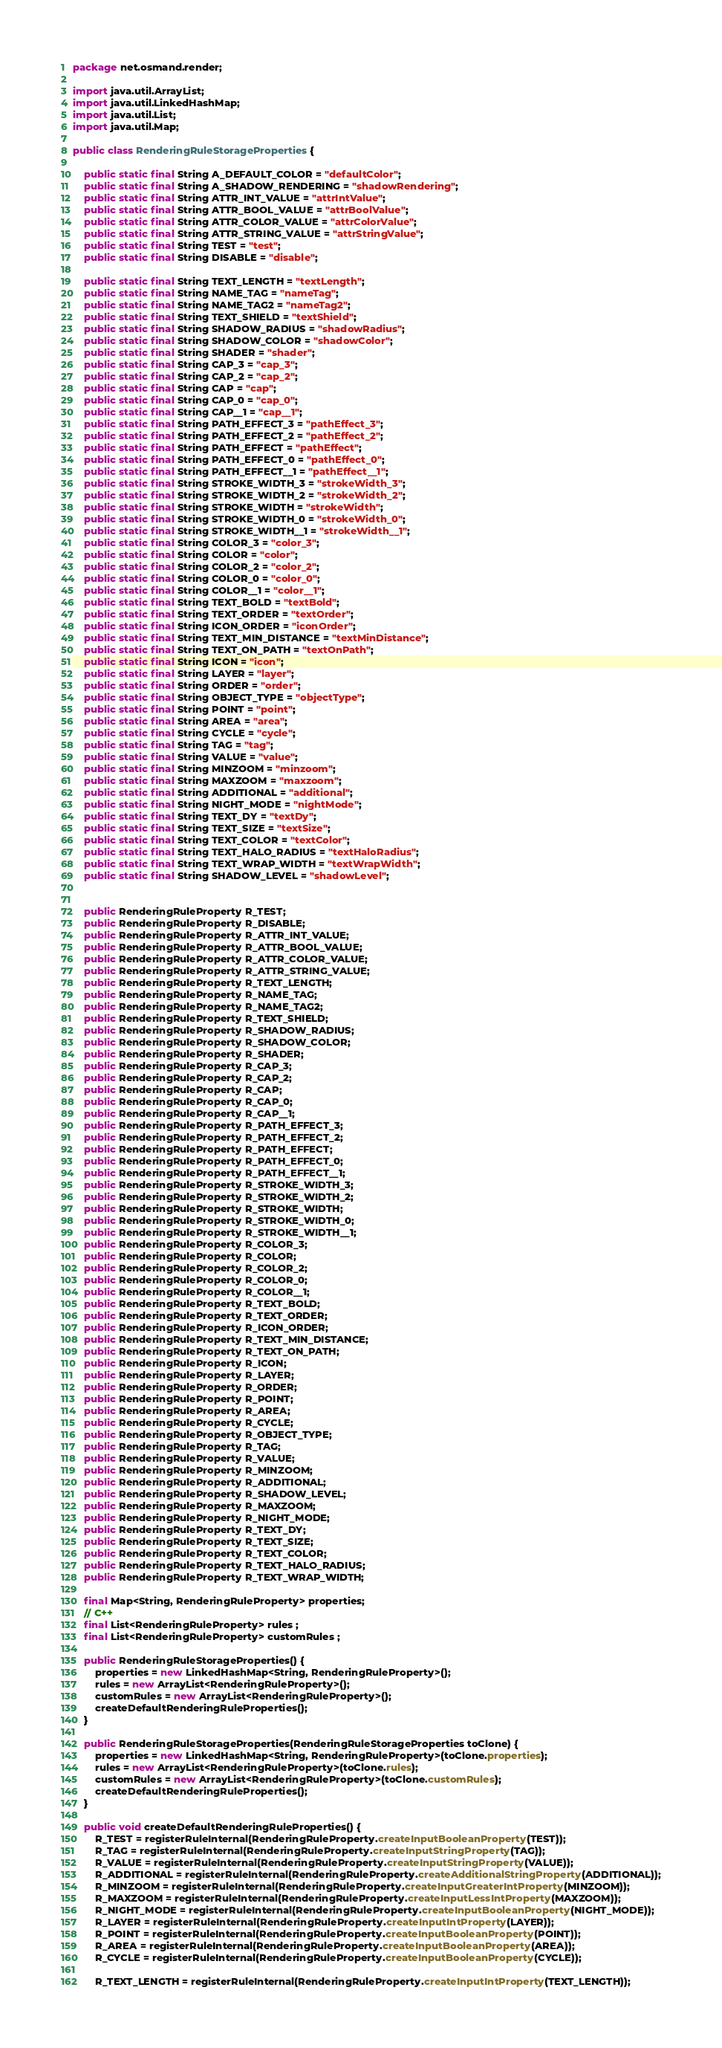<code> <loc_0><loc_0><loc_500><loc_500><_Java_>package net.osmand.render;

import java.util.ArrayList;
import java.util.LinkedHashMap;
import java.util.List;
import java.util.Map;

public class RenderingRuleStorageProperties {

	public static final String A_DEFAULT_COLOR = "defaultColor";
	public static final String A_SHADOW_RENDERING = "shadowRendering";
	public static final String ATTR_INT_VALUE = "attrIntValue";
	public static final String ATTR_BOOL_VALUE = "attrBoolValue";
	public static final String ATTR_COLOR_VALUE = "attrColorValue";
	public static final String ATTR_STRING_VALUE = "attrStringValue";
	public static final String TEST = "test";
	public static final String DISABLE = "disable";
	
	public static final String TEXT_LENGTH = "textLength";
	public static final String NAME_TAG = "nameTag";
	public static final String NAME_TAG2 = "nameTag2";
	public static final String TEXT_SHIELD = "textShield";
	public static final String SHADOW_RADIUS = "shadowRadius";
	public static final String SHADOW_COLOR = "shadowColor";
	public static final String SHADER = "shader";
	public static final String CAP_3 = "cap_3";
	public static final String CAP_2 = "cap_2";
	public static final String CAP = "cap";
	public static final String CAP_0 = "cap_0";
	public static final String CAP__1 = "cap__1";
	public static final String PATH_EFFECT_3 = "pathEffect_3";
	public static final String PATH_EFFECT_2 = "pathEffect_2";
	public static final String PATH_EFFECT = "pathEffect";
	public static final String PATH_EFFECT_0 = "pathEffect_0";
	public static final String PATH_EFFECT__1 = "pathEffect__1";
	public static final String STROKE_WIDTH_3 = "strokeWidth_3";
	public static final String STROKE_WIDTH_2 = "strokeWidth_2";
	public static final String STROKE_WIDTH = "strokeWidth";
	public static final String STROKE_WIDTH_0 = "strokeWidth_0";
	public static final String STROKE_WIDTH__1 = "strokeWidth__1";
	public static final String COLOR_3 = "color_3";
	public static final String COLOR = "color";
	public static final String COLOR_2 = "color_2";
	public static final String COLOR_0 = "color_0";
	public static final String COLOR__1 = "color__1";
	public static final String TEXT_BOLD = "textBold";
	public static final String TEXT_ORDER = "textOrder";
	public static final String ICON_ORDER = "iconOrder";
	public static final String TEXT_MIN_DISTANCE = "textMinDistance";
	public static final String TEXT_ON_PATH = "textOnPath";
	public static final String ICON = "icon";
	public static final String LAYER = "layer";
	public static final String ORDER = "order";
	public static final String OBJECT_TYPE = "objectType";
	public static final String POINT = "point";
	public static final String AREA = "area";
	public static final String CYCLE = "cycle";
	public static final String TAG = "tag";
	public static final String VALUE = "value";
	public static final String MINZOOM = "minzoom";
	public static final String MAXZOOM = "maxzoom";
	public static final String ADDITIONAL = "additional";
	public static final String NIGHT_MODE = "nightMode";
	public static final String TEXT_DY = "textDy";
	public static final String TEXT_SIZE = "textSize";
	public static final String TEXT_COLOR = "textColor";
	public static final String TEXT_HALO_RADIUS = "textHaloRadius";
	public static final String TEXT_WRAP_WIDTH = "textWrapWidth";
	public static final String SHADOW_LEVEL = "shadowLevel";

	
	public RenderingRuleProperty R_TEST;
	public RenderingRuleProperty R_DISABLE;
	public RenderingRuleProperty R_ATTR_INT_VALUE;
	public RenderingRuleProperty R_ATTR_BOOL_VALUE;
	public RenderingRuleProperty R_ATTR_COLOR_VALUE;
	public RenderingRuleProperty R_ATTR_STRING_VALUE;
	public RenderingRuleProperty R_TEXT_LENGTH;
	public RenderingRuleProperty R_NAME_TAG;
	public RenderingRuleProperty R_NAME_TAG2;
	public RenderingRuleProperty R_TEXT_SHIELD;
	public RenderingRuleProperty R_SHADOW_RADIUS;
	public RenderingRuleProperty R_SHADOW_COLOR;
	public RenderingRuleProperty R_SHADER;
	public RenderingRuleProperty R_CAP_3;
	public RenderingRuleProperty R_CAP_2;
	public RenderingRuleProperty R_CAP;
	public RenderingRuleProperty R_CAP_0;
	public RenderingRuleProperty R_CAP__1;
	public RenderingRuleProperty R_PATH_EFFECT_3;
	public RenderingRuleProperty R_PATH_EFFECT_2;
	public RenderingRuleProperty R_PATH_EFFECT;
	public RenderingRuleProperty R_PATH_EFFECT_0;
	public RenderingRuleProperty R_PATH_EFFECT__1;
	public RenderingRuleProperty R_STROKE_WIDTH_3;
	public RenderingRuleProperty R_STROKE_WIDTH_2;
	public RenderingRuleProperty R_STROKE_WIDTH;
	public RenderingRuleProperty R_STROKE_WIDTH_0;
	public RenderingRuleProperty R_STROKE_WIDTH__1;
	public RenderingRuleProperty R_COLOR_3;
	public RenderingRuleProperty R_COLOR;
	public RenderingRuleProperty R_COLOR_2;
	public RenderingRuleProperty R_COLOR_0;
	public RenderingRuleProperty R_COLOR__1;
	public RenderingRuleProperty R_TEXT_BOLD;
	public RenderingRuleProperty R_TEXT_ORDER;
	public RenderingRuleProperty R_ICON_ORDER;
	public RenderingRuleProperty R_TEXT_MIN_DISTANCE;
	public RenderingRuleProperty R_TEXT_ON_PATH;
	public RenderingRuleProperty R_ICON;
	public RenderingRuleProperty R_LAYER;
	public RenderingRuleProperty R_ORDER;
	public RenderingRuleProperty R_POINT;
	public RenderingRuleProperty R_AREA;
	public RenderingRuleProperty R_CYCLE;
	public RenderingRuleProperty R_OBJECT_TYPE;
	public RenderingRuleProperty R_TAG;
	public RenderingRuleProperty R_VALUE;
	public RenderingRuleProperty R_MINZOOM;
	public RenderingRuleProperty R_ADDITIONAL;
	public RenderingRuleProperty R_SHADOW_LEVEL;
	public RenderingRuleProperty R_MAXZOOM;
	public RenderingRuleProperty R_NIGHT_MODE;
	public RenderingRuleProperty R_TEXT_DY;
	public RenderingRuleProperty R_TEXT_SIZE;
	public RenderingRuleProperty R_TEXT_COLOR;
	public RenderingRuleProperty R_TEXT_HALO_RADIUS;
	public RenderingRuleProperty R_TEXT_WRAP_WIDTH;

	final Map<String, RenderingRuleProperty> properties;
	// C++
	final List<RenderingRuleProperty> rules ;
	final List<RenderingRuleProperty> customRules ;
	
	public RenderingRuleStorageProperties() {
		properties = new LinkedHashMap<String, RenderingRuleProperty>();
		rules = new ArrayList<RenderingRuleProperty>();
		customRules = new ArrayList<RenderingRuleProperty>();
		createDefaultRenderingRuleProperties();
	}
	
	public RenderingRuleStorageProperties(RenderingRuleStorageProperties toClone) {
		properties = new LinkedHashMap<String, RenderingRuleProperty>(toClone.properties);
		rules = new ArrayList<RenderingRuleProperty>(toClone.rules);
		customRules = new ArrayList<RenderingRuleProperty>(toClone.customRules);
		createDefaultRenderingRuleProperties();
	}

	public void createDefaultRenderingRuleProperties() {
		R_TEST = registerRuleInternal(RenderingRuleProperty.createInputBooleanProperty(TEST));
		R_TAG = registerRuleInternal(RenderingRuleProperty.createInputStringProperty(TAG));
		R_VALUE = registerRuleInternal(RenderingRuleProperty.createInputStringProperty(VALUE));
		R_ADDITIONAL = registerRuleInternal(RenderingRuleProperty.createAdditionalStringProperty(ADDITIONAL));
		R_MINZOOM = registerRuleInternal(RenderingRuleProperty.createInputGreaterIntProperty(MINZOOM));
		R_MAXZOOM = registerRuleInternal(RenderingRuleProperty.createInputLessIntProperty(MAXZOOM));
		R_NIGHT_MODE = registerRuleInternal(RenderingRuleProperty.createInputBooleanProperty(NIGHT_MODE));
		R_LAYER = registerRuleInternal(RenderingRuleProperty.createInputIntProperty(LAYER));
		R_POINT = registerRuleInternal(RenderingRuleProperty.createInputBooleanProperty(POINT));
		R_AREA = registerRuleInternal(RenderingRuleProperty.createInputBooleanProperty(AREA));
		R_CYCLE = registerRuleInternal(RenderingRuleProperty.createInputBooleanProperty(CYCLE));
		
		R_TEXT_LENGTH = registerRuleInternal(RenderingRuleProperty.createInputIntProperty(TEXT_LENGTH));</code> 